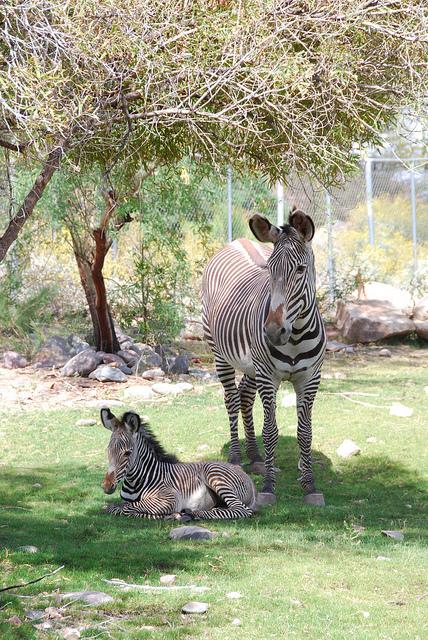What are the zebras doing in this picture?
Answer briefly. Resting. Is the zebra in the zoo?
Answer briefly. Yes. How are the zebras probably related?
Concise answer only. Mother and child. 